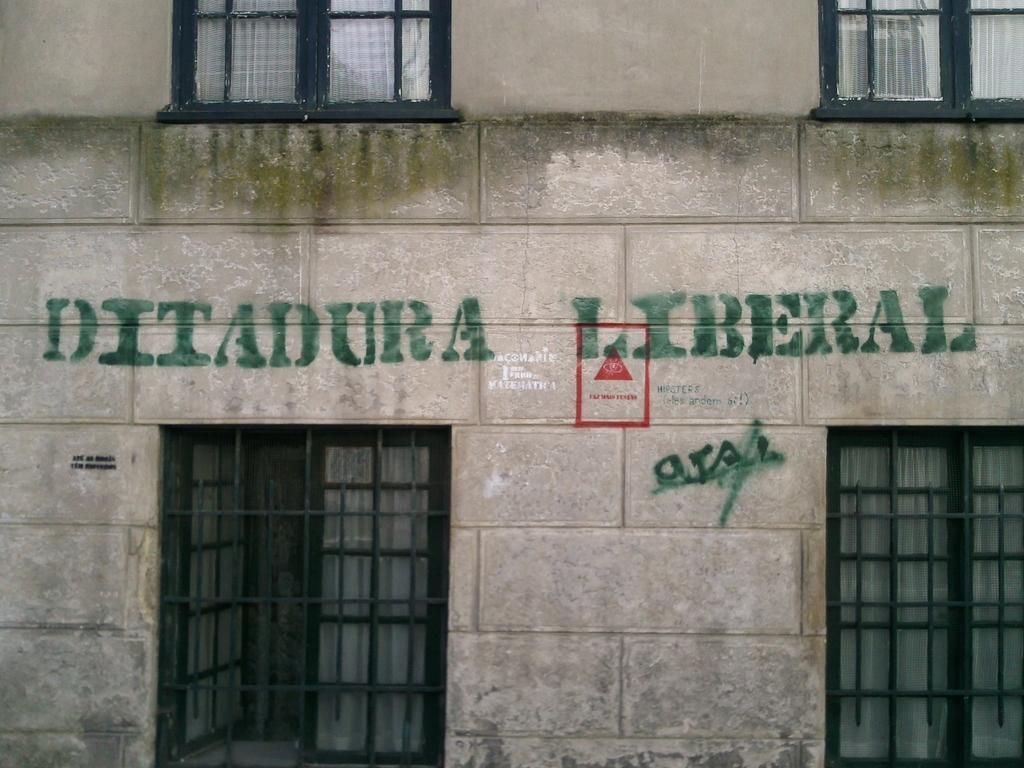How would you summarize this image in a sentence or two? In this image there are windows of the building, there is a symbol and some text on the wall of the building. 